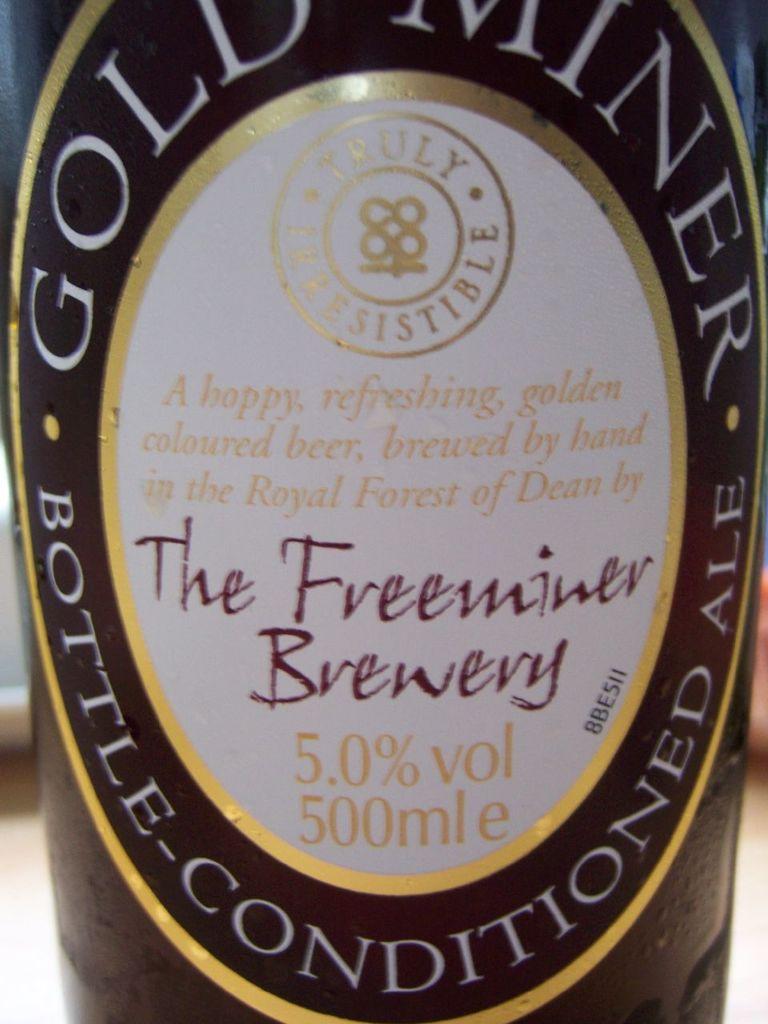What is the volume of alcohol ?
Provide a short and direct response. 5.0%. What brewery is this beer made in?
Your response must be concise. The freeminer. 